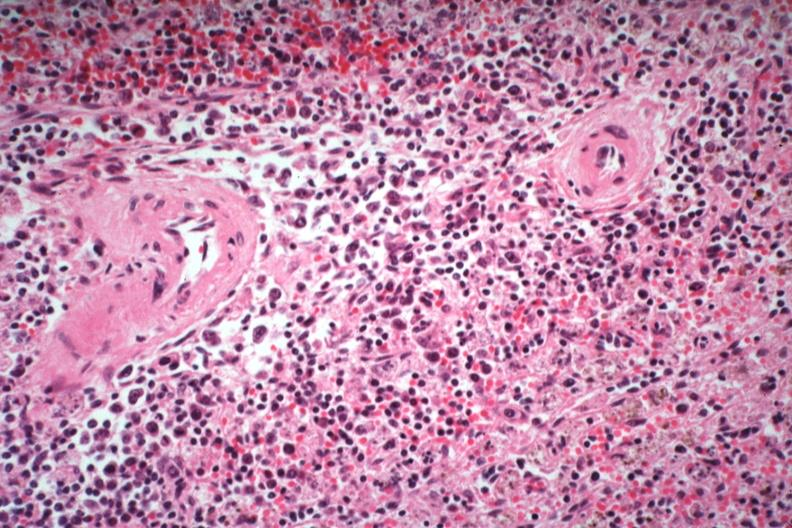what died of what was thought to be viral pneumonia probably influenza?
Answer the question using a single word or phrase. Immunoblastic type cells near splenic arteriole man 